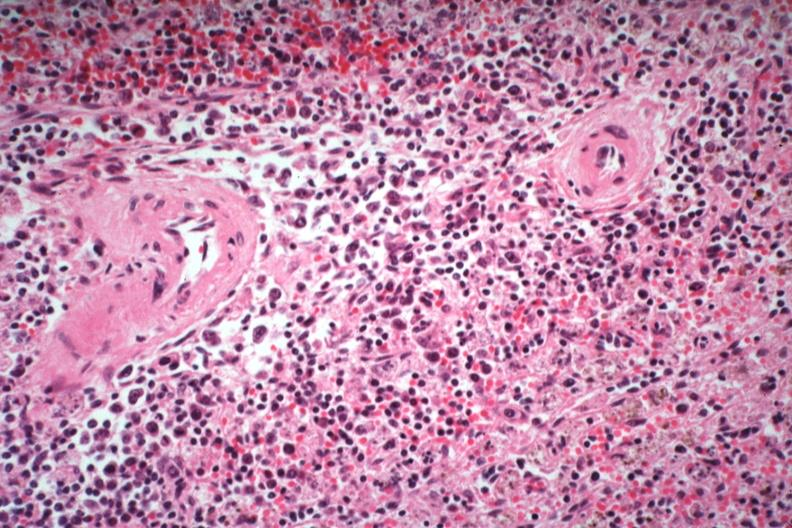what died of what was thought to be viral pneumonia probably influenza?
Answer the question using a single word or phrase. Immunoblastic type cells near splenic arteriole man 